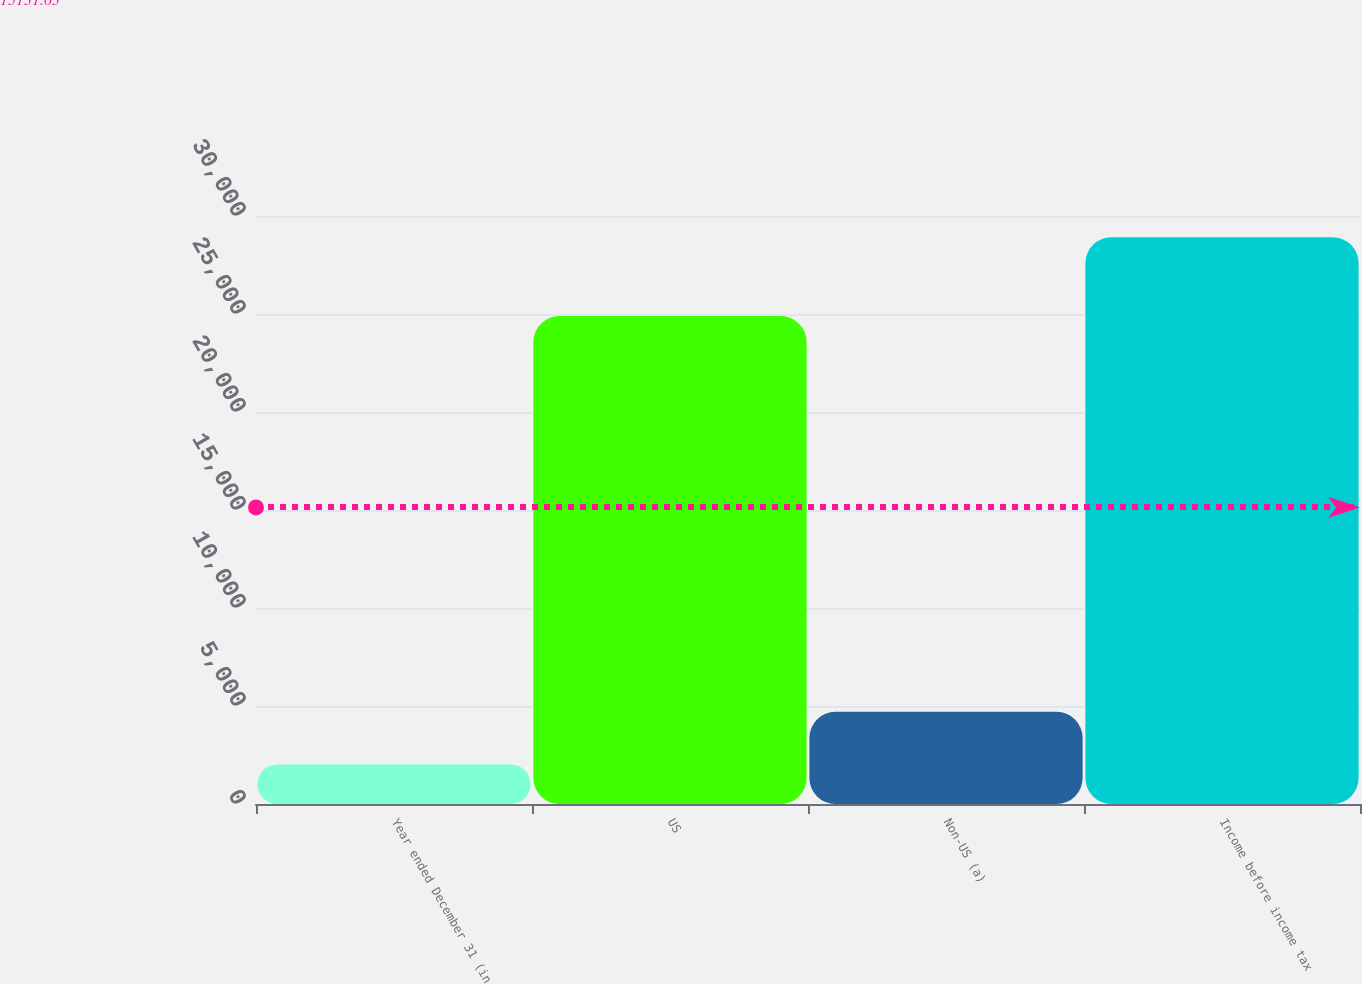Convert chart to OTSL. <chart><loc_0><loc_0><loc_500><loc_500><bar_chart><fcel>Year ended December 31 (in<fcel>US<fcel>Non-US (a)<fcel>Income before income tax<nl><fcel>2012<fcel>24895<fcel>4702.5<fcel>28917<nl></chart> 